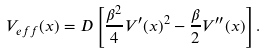Convert formula to latex. <formula><loc_0><loc_0><loc_500><loc_500>V _ { e f f } ( x ) = D \left [ \frac { \beta ^ { 2 } } { 4 } V ^ { \prime } ( x ) ^ { 2 } - \frac { \beta } { 2 } V ^ { \prime \prime } ( x ) \right ] .</formula> 